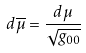Convert formula to latex. <formula><loc_0><loc_0><loc_500><loc_500>d \overline { \mu } = \frac { d \mu } { \sqrt { g _ { 0 0 } } }</formula> 